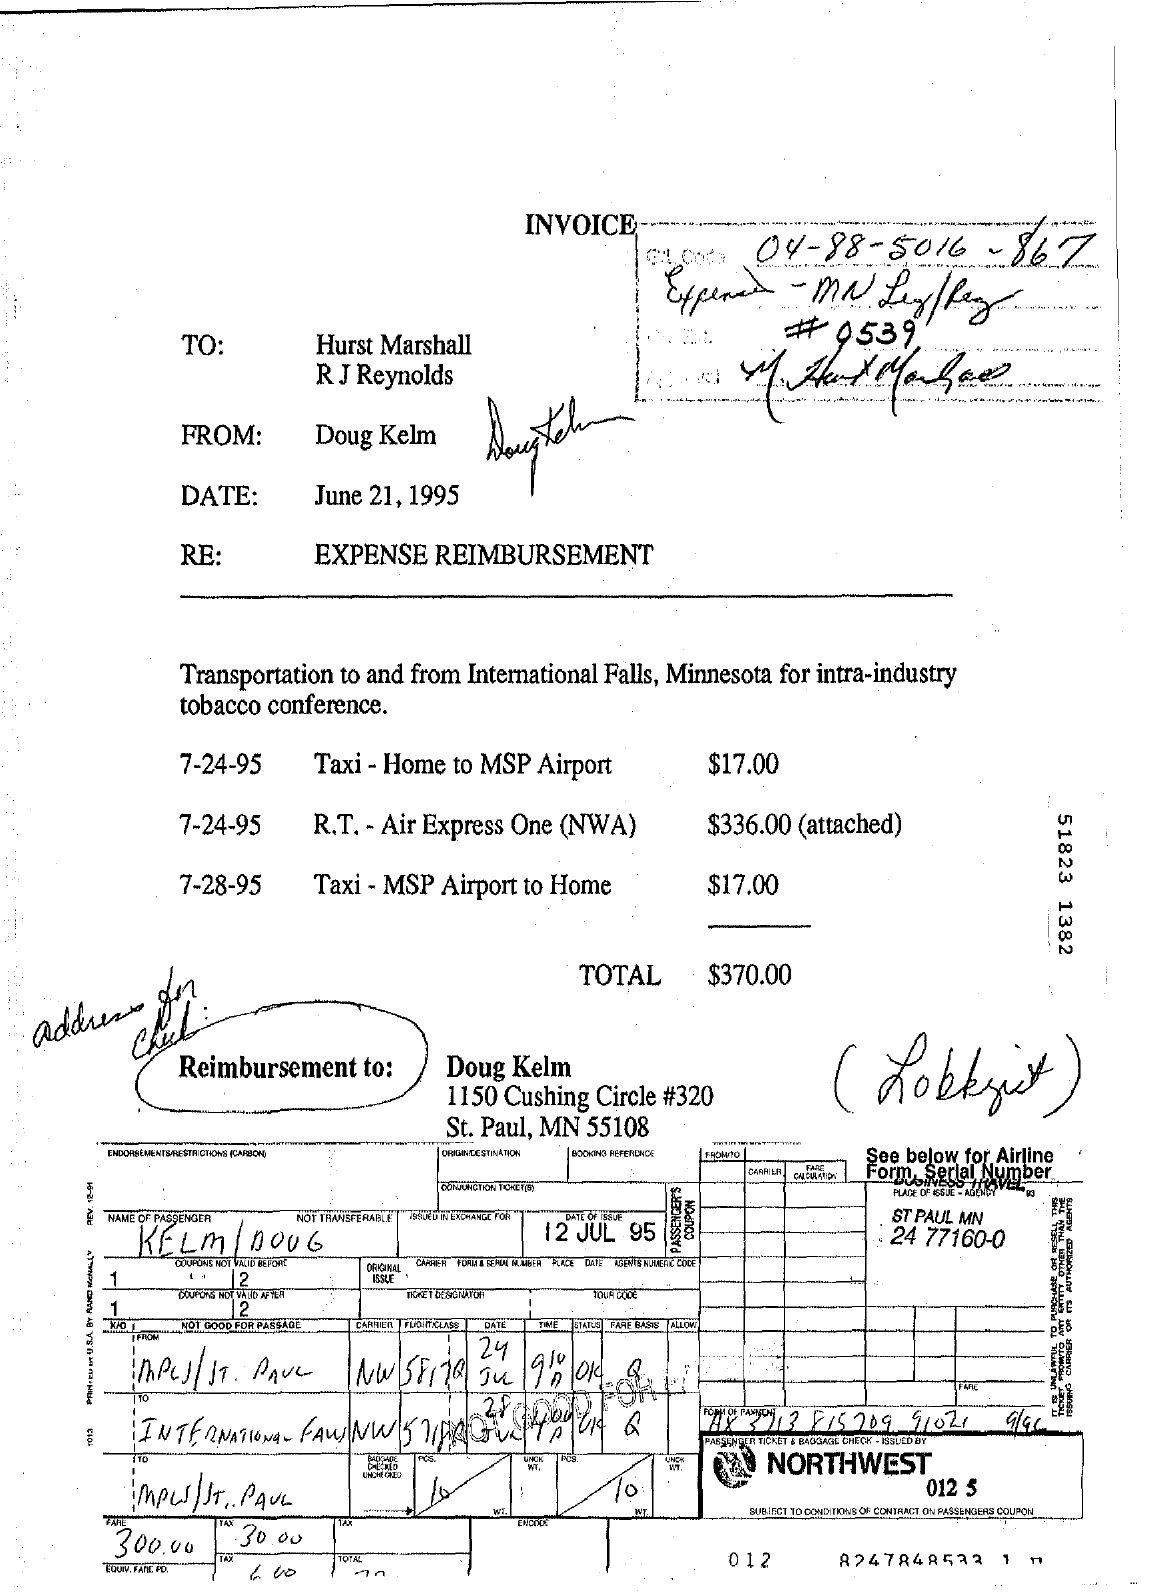Highlight a few significant elements in this photo. The total expense mentioned is $370.00. The letter is dated June 21, 1995. The RE field contains the written phrase 'EXPENSE REIMBURSEMENT,' which provides information about the purpose of the transaction. The sender is Doug Kelm. 